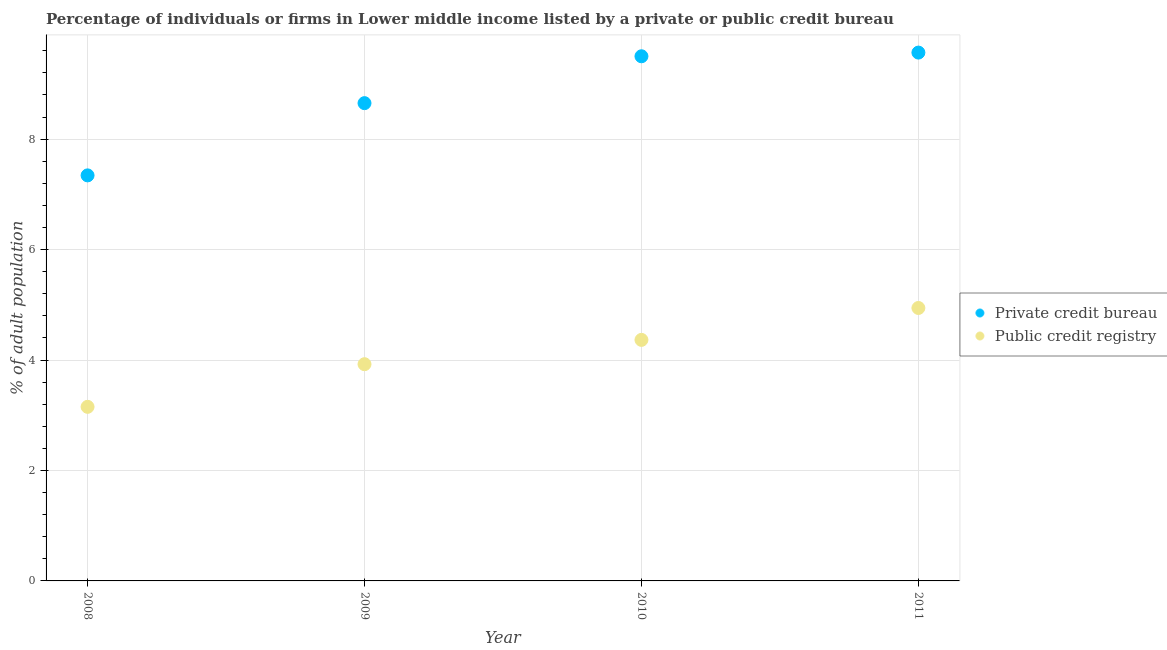How many different coloured dotlines are there?
Ensure brevity in your answer.  2. What is the percentage of firms listed by private credit bureau in 2009?
Your answer should be very brief. 8.65. Across all years, what is the maximum percentage of firms listed by private credit bureau?
Your answer should be compact. 9.57. Across all years, what is the minimum percentage of firms listed by private credit bureau?
Make the answer very short. 7.34. In which year was the percentage of firms listed by private credit bureau maximum?
Your answer should be very brief. 2011. In which year was the percentage of firms listed by private credit bureau minimum?
Provide a short and direct response. 2008. What is the total percentage of firms listed by private credit bureau in the graph?
Keep it short and to the point. 35.06. What is the difference between the percentage of firms listed by private credit bureau in 2009 and that in 2011?
Your answer should be compact. -0.92. What is the difference between the percentage of firms listed by public credit bureau in 2011 and the percentage of firms listed by private credit bureau in 2008?
Your answer should be very brief. -2.4. What is the average percentage of firms listed by public credit bureau per year?
Ensure brevity in your answer.  4.1. In the year 2011, what is the difference between the percentage of firms listed by public credit bureau and percentage of firms listed by private credit bureau?
Your answer should be compact. -4.62. In how many years, is the percentage of firms listed by private credit bureau greater than 8.8 %?
Provide a succinct answer. 2. What is the ratio of the percentage of firms listed by public credit bureau in 2008 to that in 2010?
Provide a short and direct response. 0.72. Is the percentage of firms listed by private credit bureau in 2010 less than that in 2011?
Provide a short and direct response. Yes. What is the difference between the highest and the second highest percentage of firms listed by public credit bureau?
Ensure brevity in your answer.  0.58. What is the difference between the highest and the lowest percentage of firms listed by public credit bureau?
Offer a terse response. 1.79. Does the percentage of firms listed by private credit bureau monotonically increase over the years?
Make the answer very short. Yes. How many years are there in the graph?
Your response must be concise. 4. Are the values on the major ticks of Y-axis written in scientific E-notation?
Offer a terse response. No. Does the graph contain grids?
Make the answer very short. Yes. Where does the legend appear in the graph?
Your answer should be compact. Center right. How are the legend labels stacked?
Give a very brief answer. Vertical. What is the title of the graph?
Your response must be concise. Percentage of individuals or firms in Lower middle income listed by a private or public credit bureau. What is the label or title of the Y-axis?
Offer a terse response. % of adult population. What is the % of adult population of Private credit bureau in 2008?
Give a very brief answer. 7.34. What is the % of adult population of Public credit registry in 2008?
Give a very brief answer. 3.15. What is the % of adult population of Private credit bureau in 2009?
Give a very brief answer. 8.65. What is the % of adult population of Public credit registry in 2009?
Offer a terse response. 3.92. What is the % of adult population of Private credit bureau in 2010?
Ensure brevity in your answer.  9.5. What is the % of adult population of Public credit registry in 2010?
Make the answer very short. 4.36. What is the % of adult population of Private credit bureau in 2011?
Provide a short and direct response. 9.57. What is the % of adult population in Public credit registry in 2011?
Make the answer very short. 4.94. Across all years, what is the maximum % of adult population in Private credit bureau?
Give a very brief answer. 9.57. Across all years, what is the maximum % of adult population in Public credit registry?
Your answer should be compact. 4.94. Across all years, what is the minimum % of adult population in Private credit bureau?
Provide a succinct answer. 7.34. Across all years, what is the minimum % of adult population of Public credit registry?
Make the answer very short. 3.15. What is the total % of adult population in Private credit bureau in the graph?
Your response must be concise. 35.06. What is the total % of adult population of Public credit registry in the graph?
Your answer should be very brief. 16.38. What is the difference between the % of adult population of Private credit bureau in 2008 and that in 2009?
Make the answer very short. -1.31. What is the difference between the % of adult population in Public credit registry in 2008 and that in 2009?
Offer a very short reply. -0.77. What is the difference between the % of adult population in Private credit bureau in 2008 and that in 2010?
Provide a succinct answer. -2.16. What is the difference between the % of adult population in Public credit registry in 2008 and that in 2010?
Ensure brevity in your answer.  -1.21. What is the difference between the % of adult population in Private credit bureau in 2008 and that in 2011?
Your response must be concise. -2.22. What is the difference between the % of adult population in Public credit registry in 2008 and that in 2011?
Provide a short and direct response. -1.79. What is the difference between the % of adult population of Private credit bureau in 2009 and that in 2010?
Provide a short and direct response. -0.85. What is the difference between the % of adult population of Public credit registry in 2009 and that in 2010?
Your answer should be compact. -0.44. What is the difference between the % of adult population of Private credit bureau in 2009 and that in 2011?
Make the answer very short. -0.92. What is the difference between the % of adult population in Public credit registry in 2009 and that in 2011?
Keep it short and to the point. -1.02. What is the difference between the % of adult population of Private credit bureau in 2010 and that in 2011?
Give a very brief answer. -0.07. What is the difference between the % of adult population in Public credit registry in 2010 and that in 2011?
Give a very brief answer. -0.58. What is the difference between the % of adult population in Private credit bureau in 2008 and the % of adult population in Public credit registry in 2009?
Give a very brief answer. 3.42. What is the difference between the % of adult population in Private credit bureau in 2008 and the % of adult population in Public credit registry in 2010?
Ensure brevity in your answer.  2.98. What is the difference between the % of adult population of Private credit bureau in 2008 and the % of adult population of Public credit registry in 2011?
Give a very brief answer. 2.4. What is the difference between the % of adult population in Private credit bureau in 2009 and the % of adult population in Public credit registry in 2010?
Ensure brevity in your answer.  4.29. What is the difference between the % of adult population in Private credit bureau in 2009 and the % of adult population in Public credit registry in 2011?
Offer a terse response. 3.71. What is the difference between the % of adult population in Private credit bureau in 2010 and the % of adult population in Public credit registry in 2011?
Offer a very short reply. 4.56. What is the average % of adult population of Private credit bureau per year?
Provide a short and direct response. 8.77. What is the average % of adult population of Public credit registry per year?
Make the answer very short. 4.1. In the year 2008, what is the difference between the % of adult population in Private credit bureau and % of adult population in Public credit registry?
Your answer should be compact. 4.19. In the year 2009, what is the difference between the % of adult population in Private credit bureau and % of adult population in Public credit registry?
Provide a short and direct response. 4.73. In the year 2010, what is the difference between the % of adult population of Private credit bureau and % of adult population of Public credit registry?
Keep it short and to the point. 5.14. In the year 2011, what is the difference between the % of adult population in Private credit bureau and % of adult population in Public credit registry?
Your response must be concise. 4.62. What is the ratio of the % of adult population of Private credit bureau in 2008 to that in 2009?
Offer a very short reply. 0.85. What is the ratio of the % of adult population of Public credit registry in 2008 to that in 2009?
Keep it short and to the point. 0.8. What is the ratio of the % of adult population of Private credit bureau in 2008 to that in 2010?
Keep it short and to the point. 0.77. What is the ratio of the % of adult population in Public credit registry in 2008 to that in 2010?
Give a very brief answer. 0.72. What is the ratio of the % of adult population in Private credit bureau in 2008 to that in 2011?
Your answer should be compact. 0.77. What is the ratio of the % of adult population of Public credit registry in 2008 to that in 2011?
Provide a short and direct response. 0.64. What is the ratio of the % of adult population of Private credit bureau in 2009 to that in 2010?
Keep it short and to the point. 0.91. What is the ratio of the % of adult population in Public credit registry in 2009 to that in 2010?
Make the answer very short. 0.9. What is the ratio of the % of adult population in Private credit bureau in 2009 to that in 2011?
Give a very brief answer. 0.9. What is the ratio of the % of adult population of Public credit registry in 2009 to that in 2011?
Ensure brevity in your answer.  0.79. What is the ratio of the % of adult population in Public credit registry in 2010 to that in 2011?
Keep it short and to the point. 0.88. What is the difference between the highest and the second highest % of adult population of Private credit bureau?
Provide a succinct answer. 0.07. What is the difference between the highest and the second highest % of adult population in Public credit registry?
Your answer should be compact. 0.58. What is the difference between the highest and the lowest % of adult population of Private credit bureau?
Keep it short and to the point. 2.22. What is the difference between the highest and the lowest % of adult population of Public credit registry?
Give a very brief answer. 1.79. 